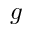Convert formula to latex. <formula><loc_0><loc_0><loc_500><loc_500>g</formula> 